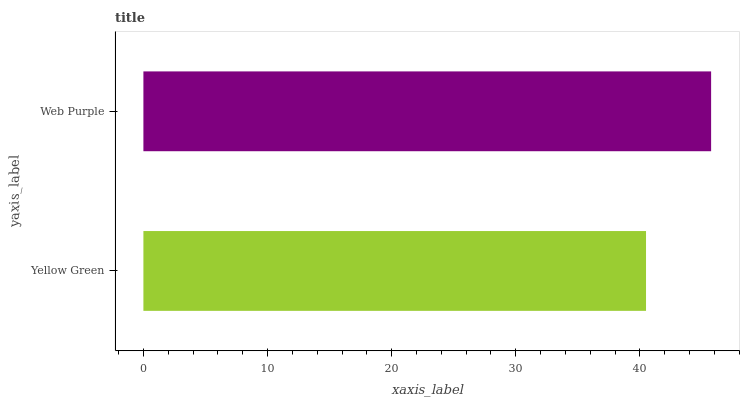Is Yellow Green the minimum?
Answer yes or no. Yes. Is Web Purple the maximum?
Answer yes or no. Yes. Is Web Purple the minimum?
Answer yes or no. No. Is Web Purple greater than Yellow Green?
Answer yes or no. Yes. Is Yellow Green less than Web Purple?
Answer yes or no. Yes. Is Yellow Green greater than Web Purple?
Answer yes or no. No. Is Web Purple less than Yellow Green?
Answer yes or no. No. Is Web Purple the high median?
Answer yes or no. Yes. Is Yellow Green the low median?
Answer yes or no. Yes. Is Yellow Green the high median?
Answer yes or no. No. Is Web Purple the low median?
Answer yes or no. No. 